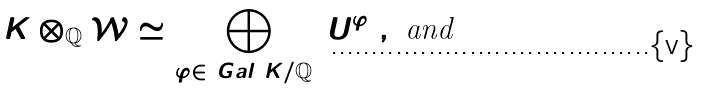<formula> <loc_0><loc_0><loc_500><loc_500>K \otimes _ { \mathbb { Q } } \mathcal { W } \simeq \bigoplus _ { \varphi \in \ G a l ( K / \mathbb { Q } ) } U ^ { \varphi } \ , \text { and }</formula> 